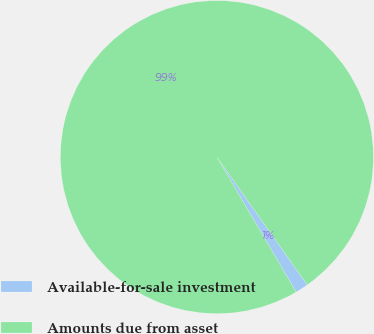<chart> <loc_0><loc_0><loc_500><loc_500><pie_chart><fcel>Available-for-sale investment<fcel>Amounts due from asset<nl><fcel>1.34%<fcel>98.66%<nl></chart> 